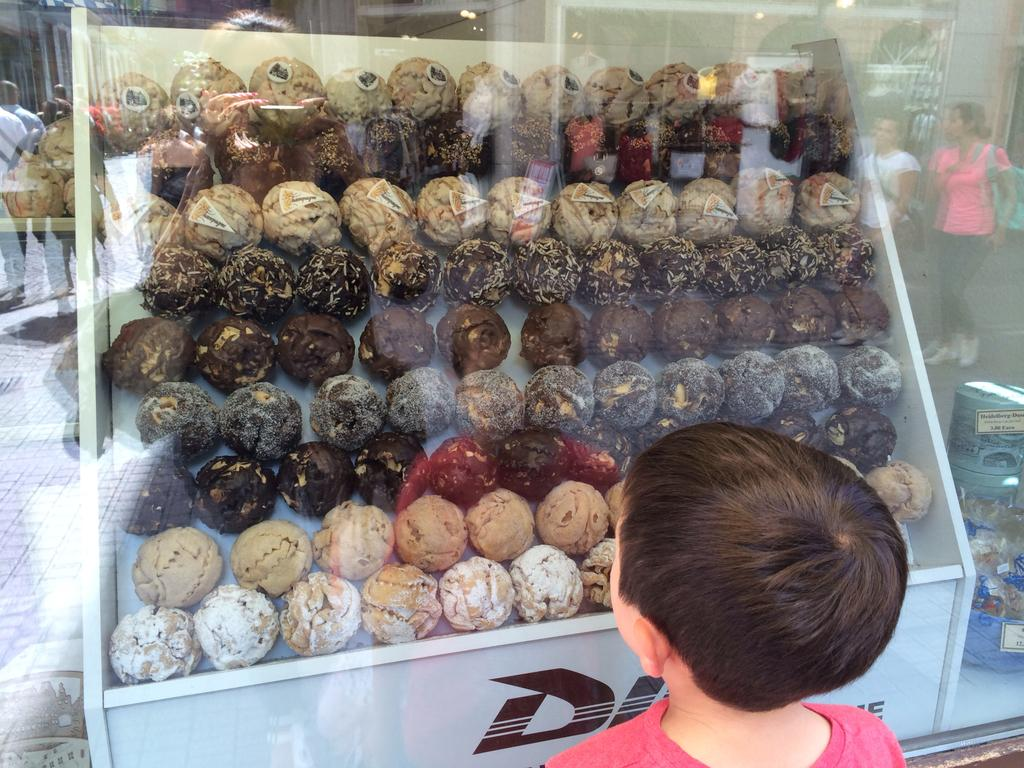Who or what can be seen in the image? There are people in the image. What can be seen in the distance behind the people? There are buildings in the background of the image. Can you describe the clothing of one of the people in the image? A boy is wearing a pink t-shirt. What type of fruit is present in the image? There are apricots in the image. What type of coal is being used to fuel the fight in the image? There is no fight or coal present in the image. 